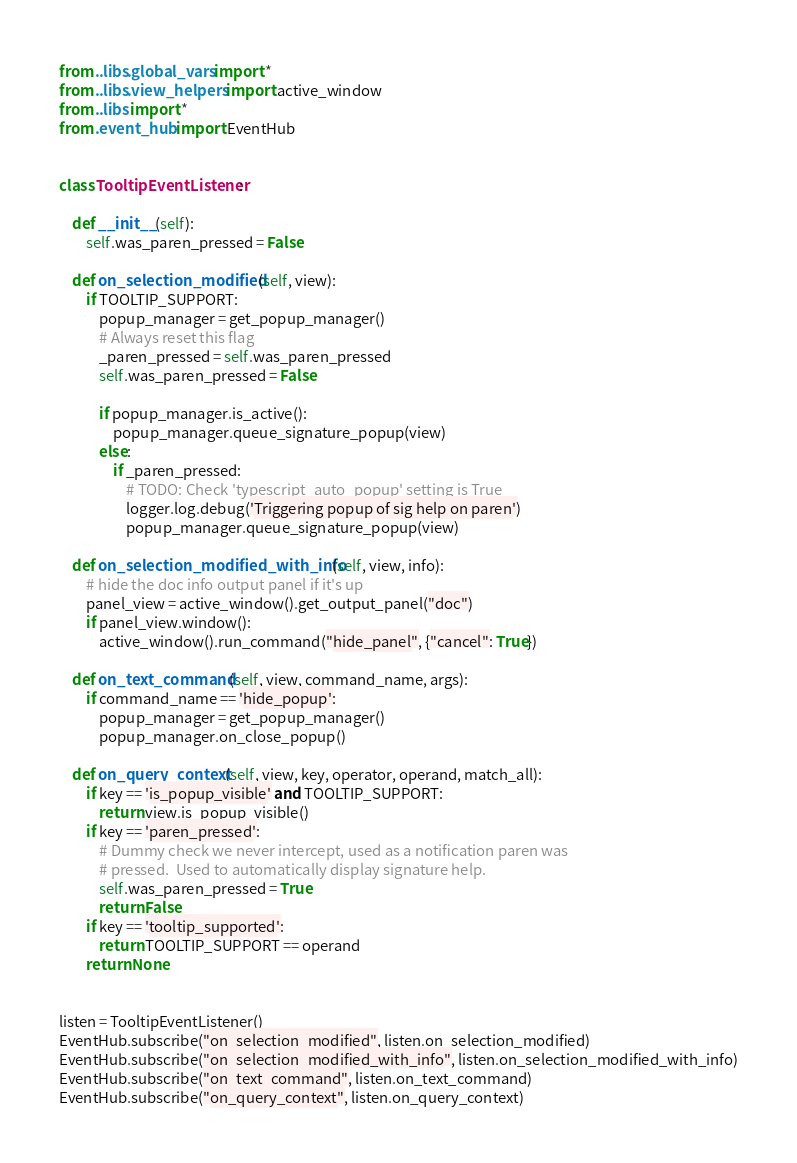Convert code to text. <code><loc_0><loc_0><loc_500><loc_500><_Python_>from ..libs.global_vars import *
from ..libs.view_helpers import active_window
from ..libs import *
from .event_hub import EventHub


class TooltipEventListener:

    def __init__(self):
        self.was_paren_pressed = False

    def on_selection_modified(self, view):
        if TOOLTIP_SUPPORT:
            popup_manager = get_popup_manager()
            # Always reset this flag
            _paren_pressed = self.was_paren_pressed
            self.was_paren_pressed = False

            if popup_manager.is_active():
                popup_manager.queue_signature_popup(view)
            else:
                if _paren_pressed:
                    # TODO: Check 'typescript_auto_popup' setting is True
                    logger.log.debug('Triggering popup of sig help on paren')
                    popup_manager.queue_signature_popup(view)

    def on_selection_modified_with_info(self, view, info):
        # hide the doc info output panel if it's up
        panel_view = active_window().get_output_panel("doc")
        if panel_view.window():
            active_window().run_command("hide_panel", {"cancel": True})

    def on_text_command(self, view, command_name, args):
        if command_name == 'hide_popup':
            popup_manager = get_popup_manager()
            popup_manager.on_close_popup()

    def on_query_context(self, view, key, operator, operand, match_all):
        if key == 'is_popup_visible' and TOOLTIP_SUPPORT:
            return view.is_popup_visible()
        if key == 'paren_pressed':
            # Dummy check we never intercept, used as a notification paren was
            # pressed.  Used to automatically display signature help.
            self.was_paren_pressed = True
            return False
        if key == 'tooltip_supported':
            return TOOLTIP_SUPPORT == operand
        return None


listen = TooltipEventListener()
EventHub.subscribe("on_selection_modified", listen.on_selection_modified)
EventHub.subscribe("on_selection_modified_with_info", listen.on_selection_modified_with_info)
EventHub.subscribe("on_text_command", listen.on_text_command)
EventHub.subscribe("on_query_context", listen.on_query_context)
</code> 